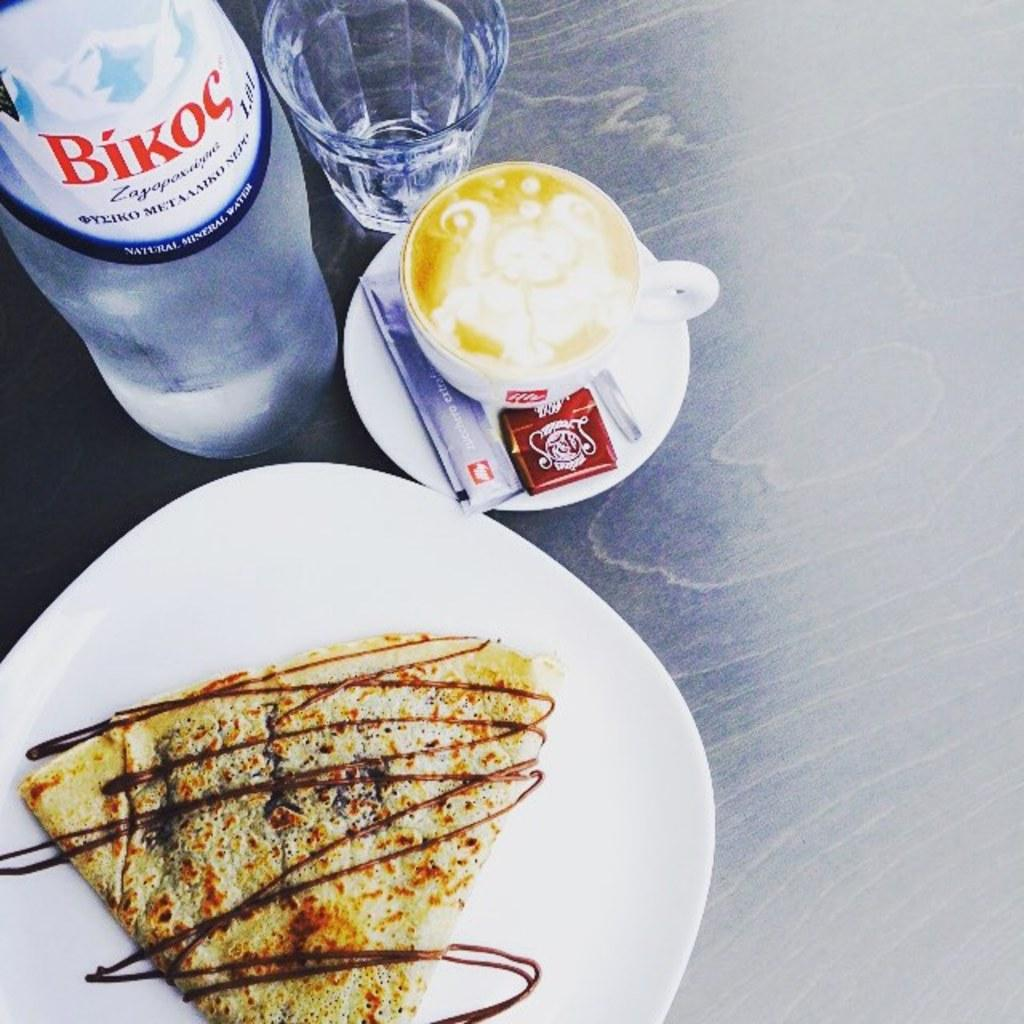<image>
Present a compact description of the photo's key features. A bottle of water with the label Bikoc on it. 